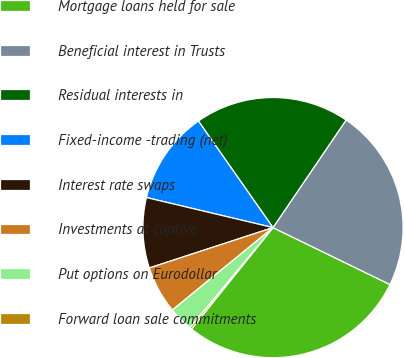Convert chart to OTSL. <chart><loc_0><loc_0><loc_500><loc_500><pie_chart><fcel>Mortgage loans held for sale<fcel>Beneficial interest in Trusts<fcel>Residual interests in<fcel>Fixed-income -trading (net)<fcel>Interest rate swaps<fcel>Investments at captive<fcel>Put options on Eurodollar<fcel>Forward loan sale commitments<nl><fcel>28.56%<fcel>22.71%<fcel>19.22%<fcel>11.57%<fcel>8.73%<fcel>5.9%<fcel>3.07%<fcel>0.24%<nl></chart> 